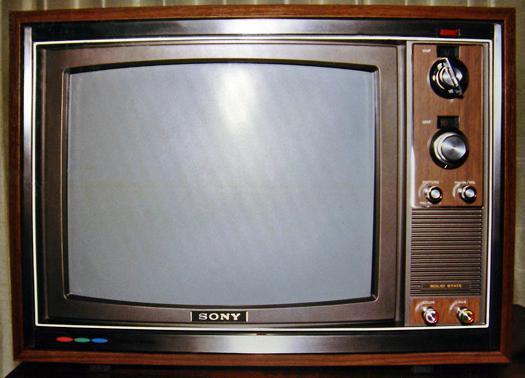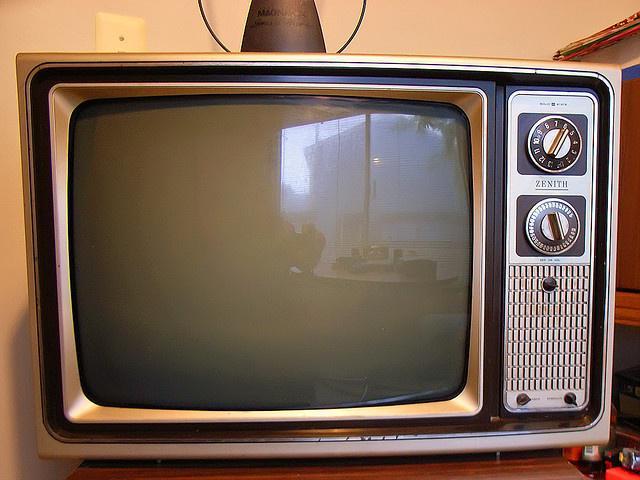The first image is the image on the left, the second image is the image on the right. Analyze the images presented: Is the assertion "There are at least two round knobs on each television." valid? Answer yes or no. Yes. The first image is the image on the left, the second image is the image on the right. For the images shown, is this caption "The screen on one of the old-fashioned TVs is glowing, showing the set is turned on." true? Answer yes or no. No. 